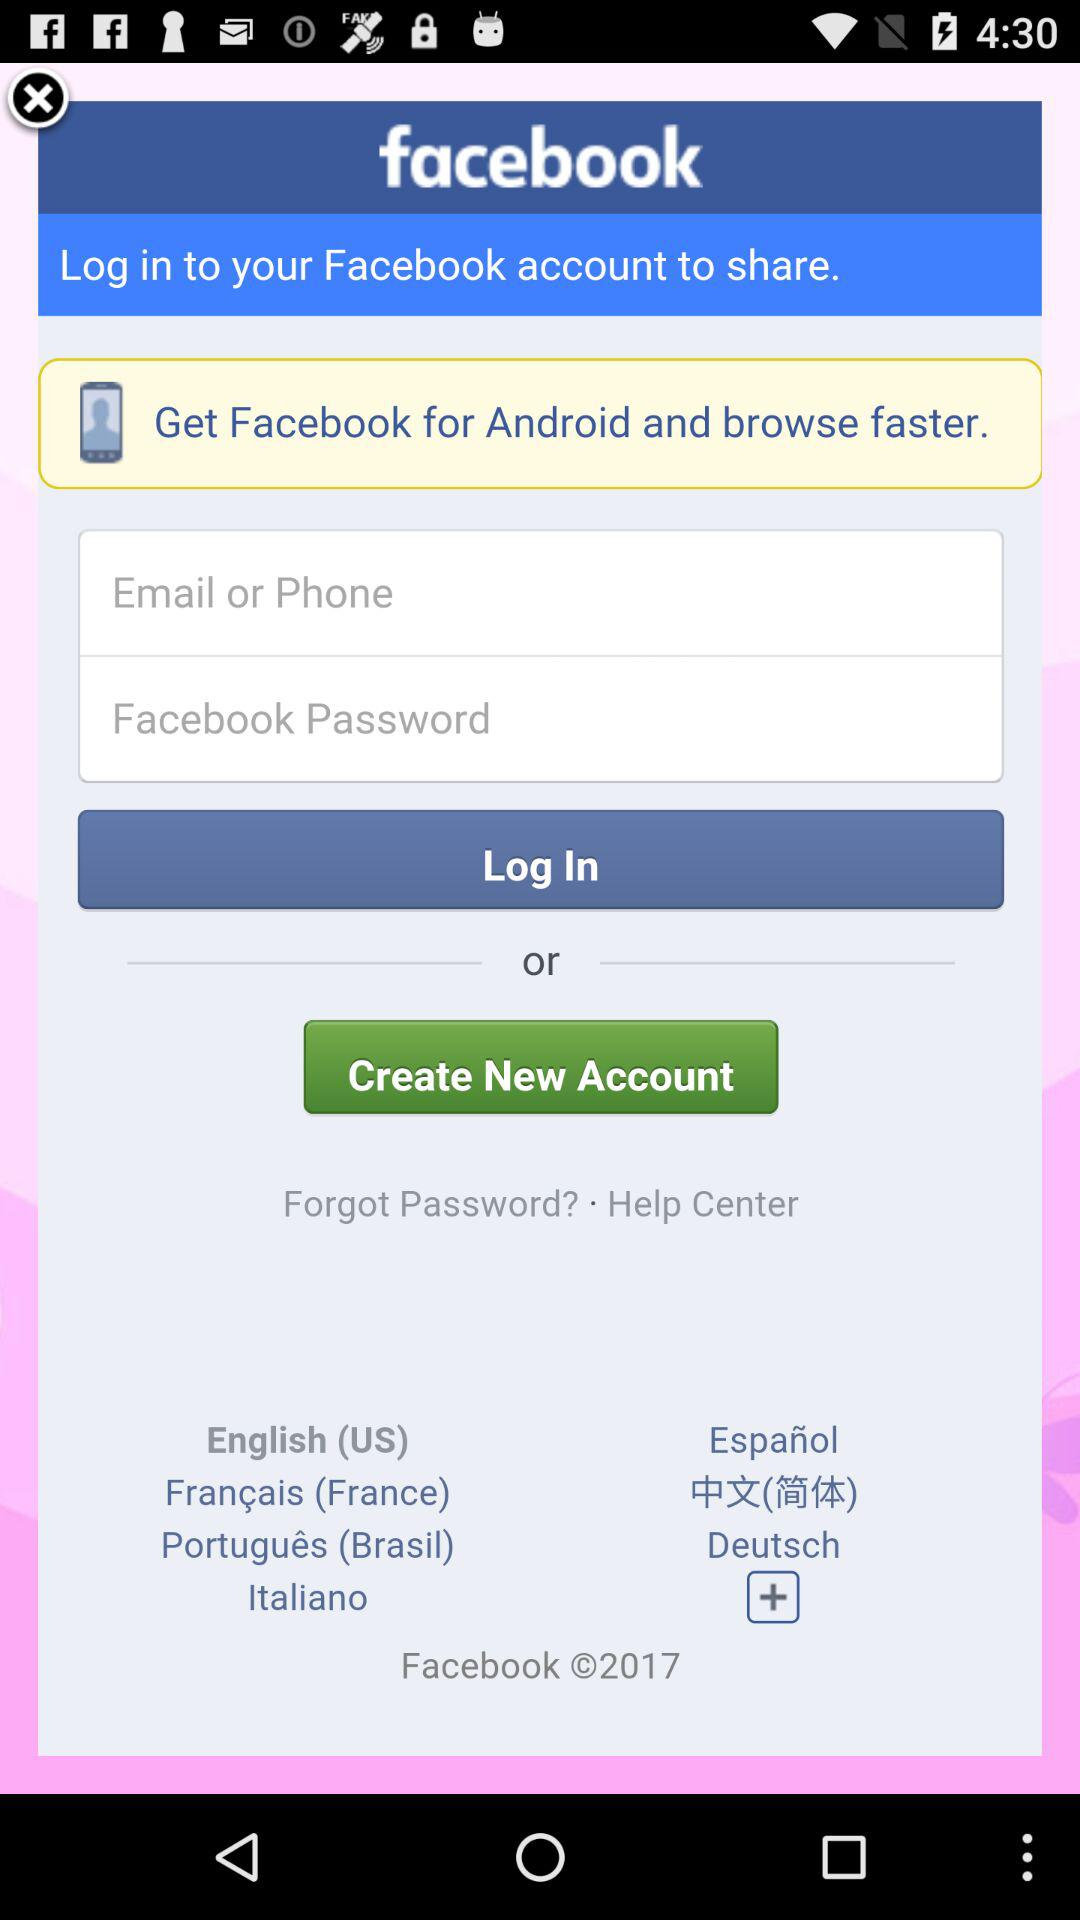What language is selected? The selected language is English (US). 